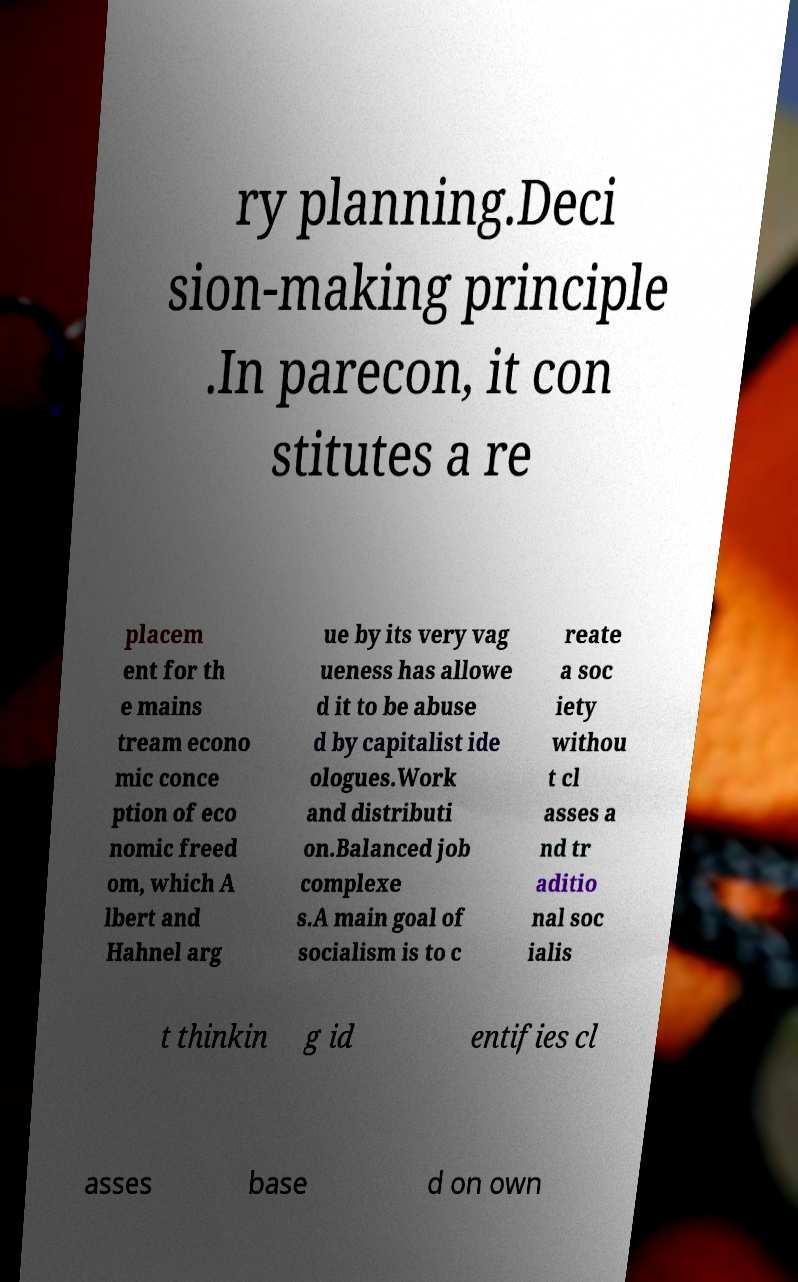Please read and relay the text visible in this image. What does it say? ry planning.Deci sion-making principle .In parecon, it con stitutes a re placem ent for th e mains tream econo mic conce ption of eco nomic freed om, which A lbert and Hahnel arg ue by its very vag ueness has allowe d it to be abuse d by capitalist ide ologues.Work and distributi on.Balanced job complexe s.A main goal of socialism is to c reate a soc iety withou t cl asses a nd tr aditio nal soc ialis t thinkin g id entifies cl asses base d on own 